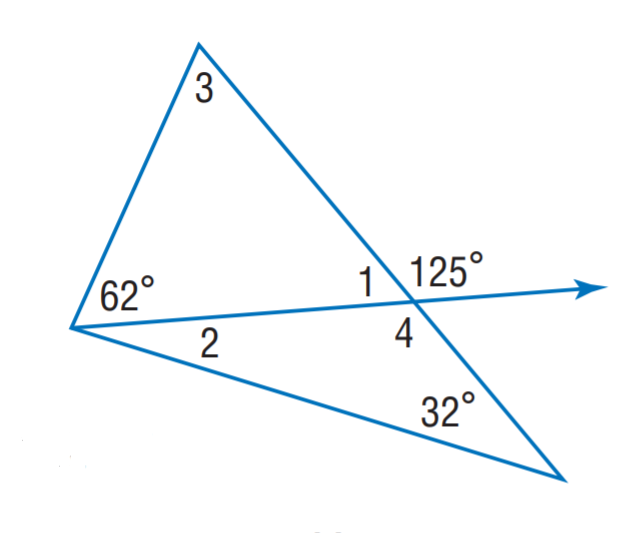Answer the mathemtical geometry problem and directly provide the correct option letter.
Question: Find m \angle 4.
Choices: A: 55 B: 63 C: 118 D: 125 D 